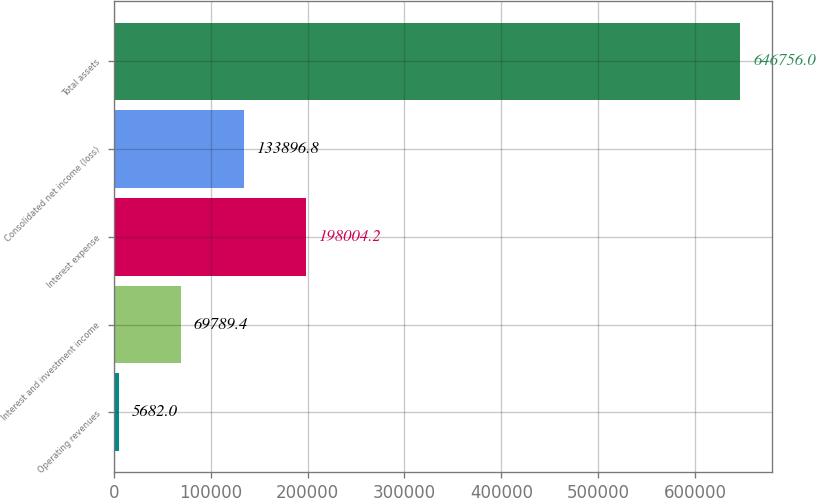Convert chart to OTSL. <chart><loc_0><loc_0><loc_500><loc_500><bar_chart><fcel>Operating revenues<fcel>Interest and investment income<fcel>Interest expense<fcel>Consolidated net income (loss)<fcel>Total assets<nl><fcel>5682<fcel>69789.4<fcel>198004<fcel>133897<fcel>646756<nl></chart> 